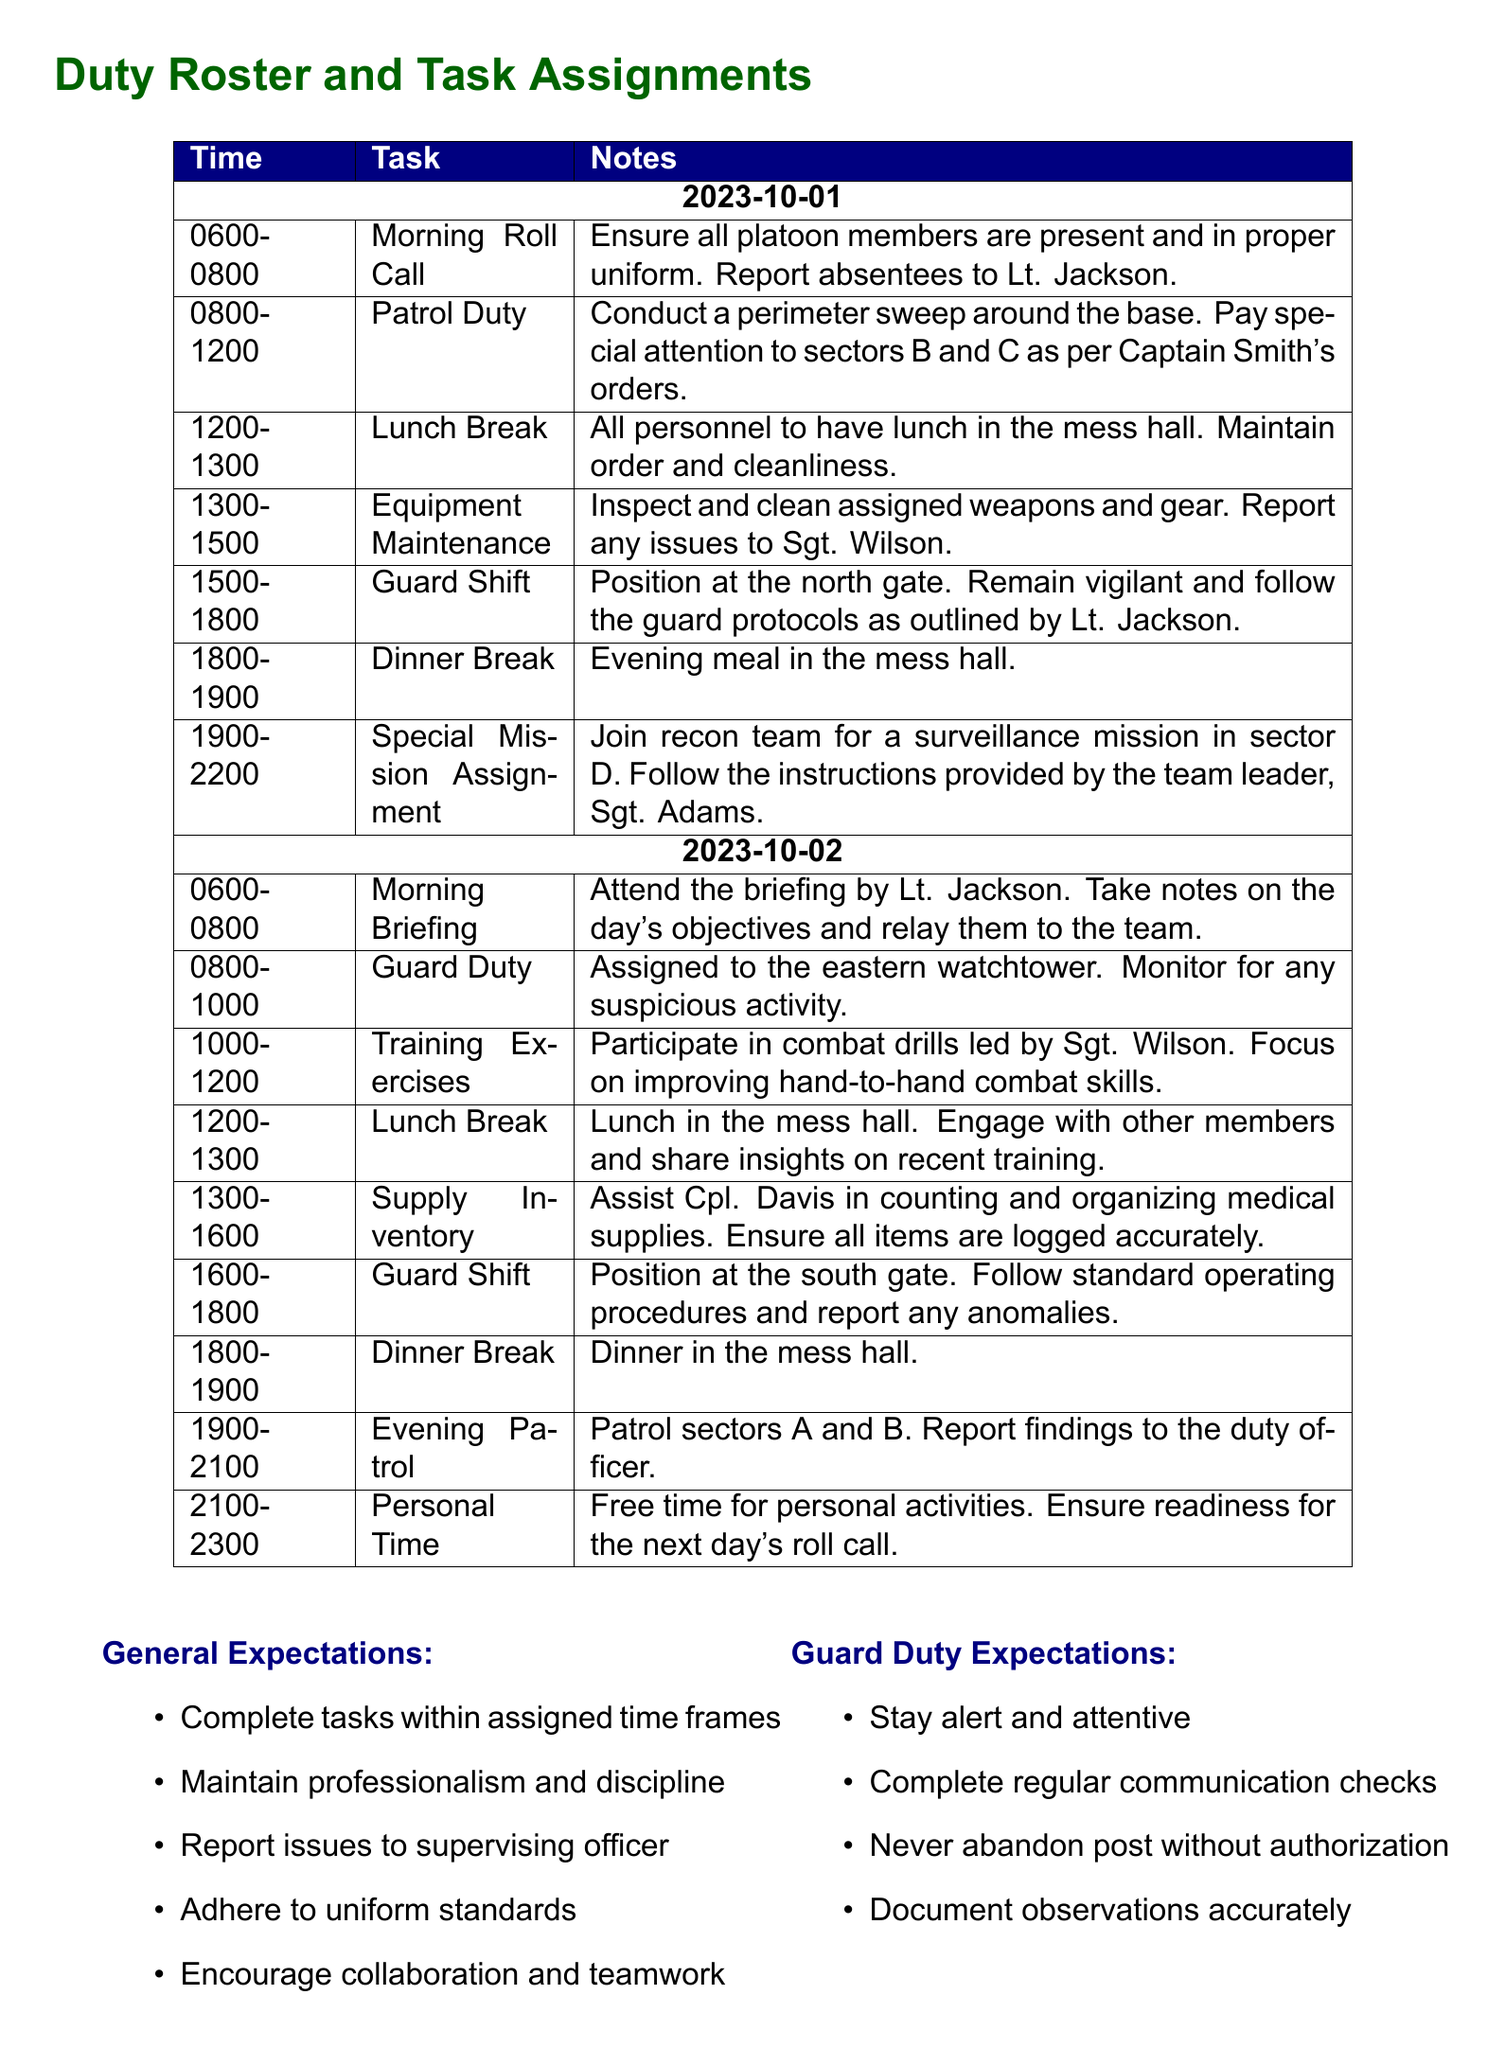What is the first task listed on October 1st? The first task listed on October 1st is "Morning Roll Call".
Answer: Morning Roll Call How long is the lunch break on October 2nd? The lunch break on October 2nd is from 1200 to 1300, which is 1 hour.
Answer: 1 hour Who is responsible for the special mission assignment on October 1st? The special mission assignment on October 1st is led by "Sgt. Adams".
Answer: Sgt. Adams What color is used for the header of the duty roster? The header of the duty roster uses the color "navy".
Answer: navy How many tasks are outlined for October 2nd? There are a total of 8 tasks outlined for October 2nd.
Answer: 8 tasks What is expected from guard duty personnel? Guard duty personnel are expected to "stay alert and attentive".
Answer: stay alert and attentive Where should personnel have their dinner on October 1st? Personnel should have their dinner in the "mess hall" on October 1st.
Answer: mess hall What is the total duration of personal time on October 2nd? The personal time on October 2nd lasts from 2100 to 2300, which is 2 hours.
Answer: 2 hours 